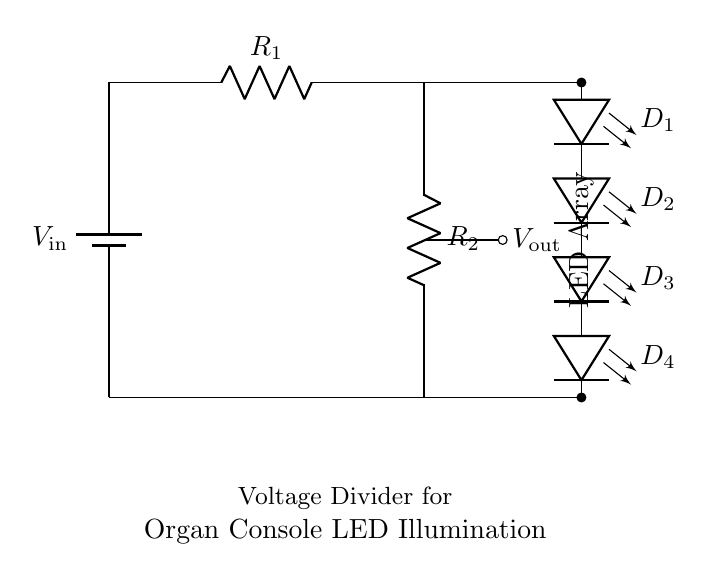What is the input voltage in the circuit? The input voltage is represented by the label `V_in` next to the battery in the circuit diagram.
Answer: V_in What are the resistors in the circuit? The circuit contains two resistors labeled `R_1` and `R_2` which are connected in series.
Answer: R_1, R_2 How many LEDs are connected in the LED array? The LED array consists of four individual LEDs labeled `D_1`, `D_2`, `D_3`, and `D_4` in the diagram.
Answer: 4 What is the output voltage source in this design? The output voltage is indicated by the label `V_out` which is located at the junction between the two resistors and to the LED array.
Answer: V_out What is the purpose of using a voltage divider in this circuit? The voltage divider is used to reduce the input voltage so that the appropriate voltage can be supplied to the LED array for desired brightness.
Answer: To control LED brightness Describe the connection between the resistors and the LEDs. The resistors `R_1` and `R_2` are in series, and the output voltage `V_out`, taken across `R_2`, supplies the voltage to the connected LED array in parallel.
Answer: Series with resistors, parallel with LEDs Which component controls the brightness of the LEDs? The brightness of the LEDs is controlled by the voltage drop across `R_2`, which varies depending on the values of `R_1` and `R_2`.
Answer: R_2 